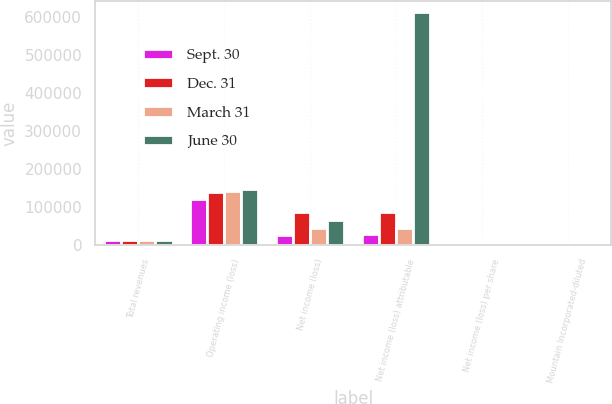Convert chart. <chart><loc_0><loc_0><loc_500><loc_500><stacked_bar_chart><ecel><fcel>Total revenues<fcel>Operating income (loss)<fcel>Net income (loss)<fcel>Net income (loss) attributable<fcel>Net income (loss) per share<fcel>Mountain Incorporated-diluted<nl><fcel>Sept. 30<fcel>13472.4<fcel>121197<fcel>26944<fcel>28799<fcel>0.12<fcel>0.14<nl><fcel>Dec. 31<fcel>13472.4<fcel>138054<fcel>87512<fcel>87638<fcel>0.2<fcel>0.43<nl><fcel>March 31<fcel>13472.4<fcel>142649<fcel>43177<fcel>43186<fcel>0.76<fcel>0.21<nl><fcel>June 30<fcel>13472.4<fcel>146644<fcel>64673<fcel>612541<fcel>0.16<fcel>0.3<nl></chart> 